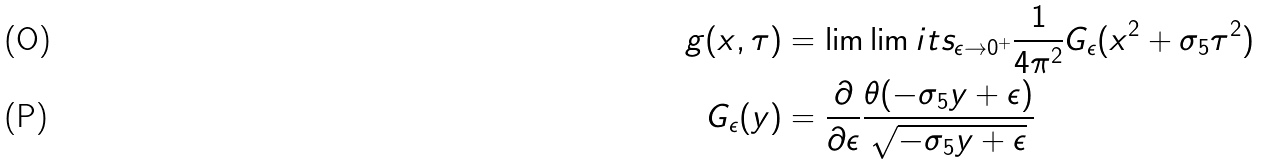Convert formula to latex. <formula><loc_0><loc_0><loc_500><loc_500>g ( x , \tau ) & = \lim \lim i t s _ { \epsilon \to 0 ^ { + } } \frac { 1 } { 4 \pi ^ { 2 } } G _ { \epsilon } ( x ^ { 2 } + \sigma _ { 5 } \tau ^ { 2 } ) \\ G _ { \epsilon } ( y ) & = \frac { \partial } { \partial \epsilon } \frac { \theta ( - \sigma _ { 5 } y + \epsilon ) } { \sqrt { - \sigma _ { 5 } y + \epsilon } }</formula> 